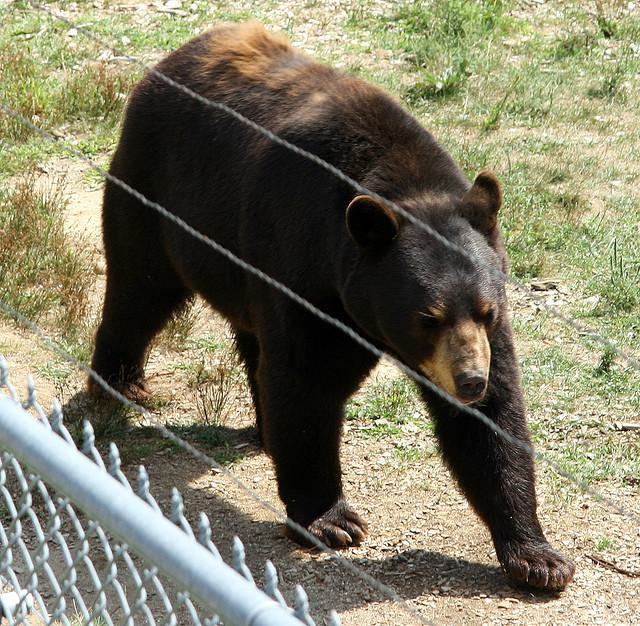What color is this bear?
Answer briefly. Brown. Is the bear behind a fence?
Answer briefly. Yes. What environment is this bear in?
Answer briefly. Zoo. Is there a bear cub in the picture?
Answer briefly. No. 